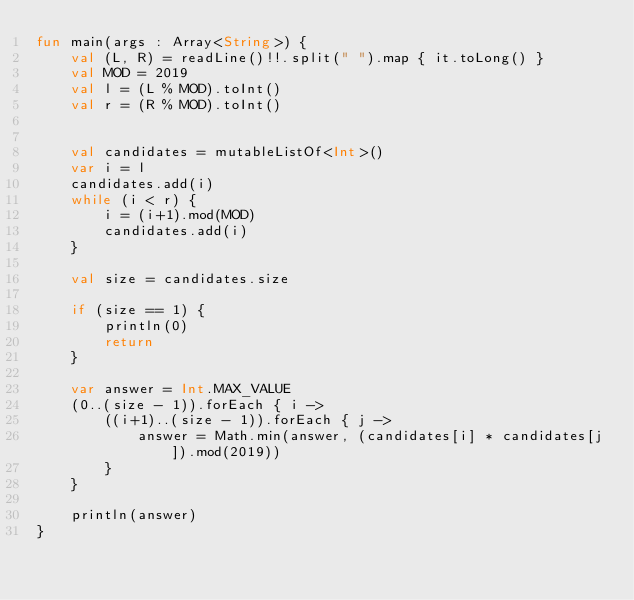<code> <loc_0><loc_0><loc_500><loc_500><_Kotlin_>fun main(args : Array<String>) {
    val (L, R) = readLine()!!.split(" ").map { it.toLong() }
    val MOD = 2019
    val l = (L % MOD).toInt()
    val r = (R % MOD).toInt()


    val candidates = mutableListOf<Int>()
    var i = l
    candidates.add(i)
    while (i < r) {
        i = (i+1).mod(MOD)
        candidates.add(i)
    }

    val size = candidates.size
    
    if (size == 1) {
        println(0)
        return
    }

    var answer = Int.MAX_VALUE
    (0..(size - 1)).forEach { i ->
        ((i+1)..(size - 1)).forEach { j ->
            answer = Math.min(answer, (candidates[i] * candidates[j]).mod(2019))
        }
    }

    println(answer)
}</code> 